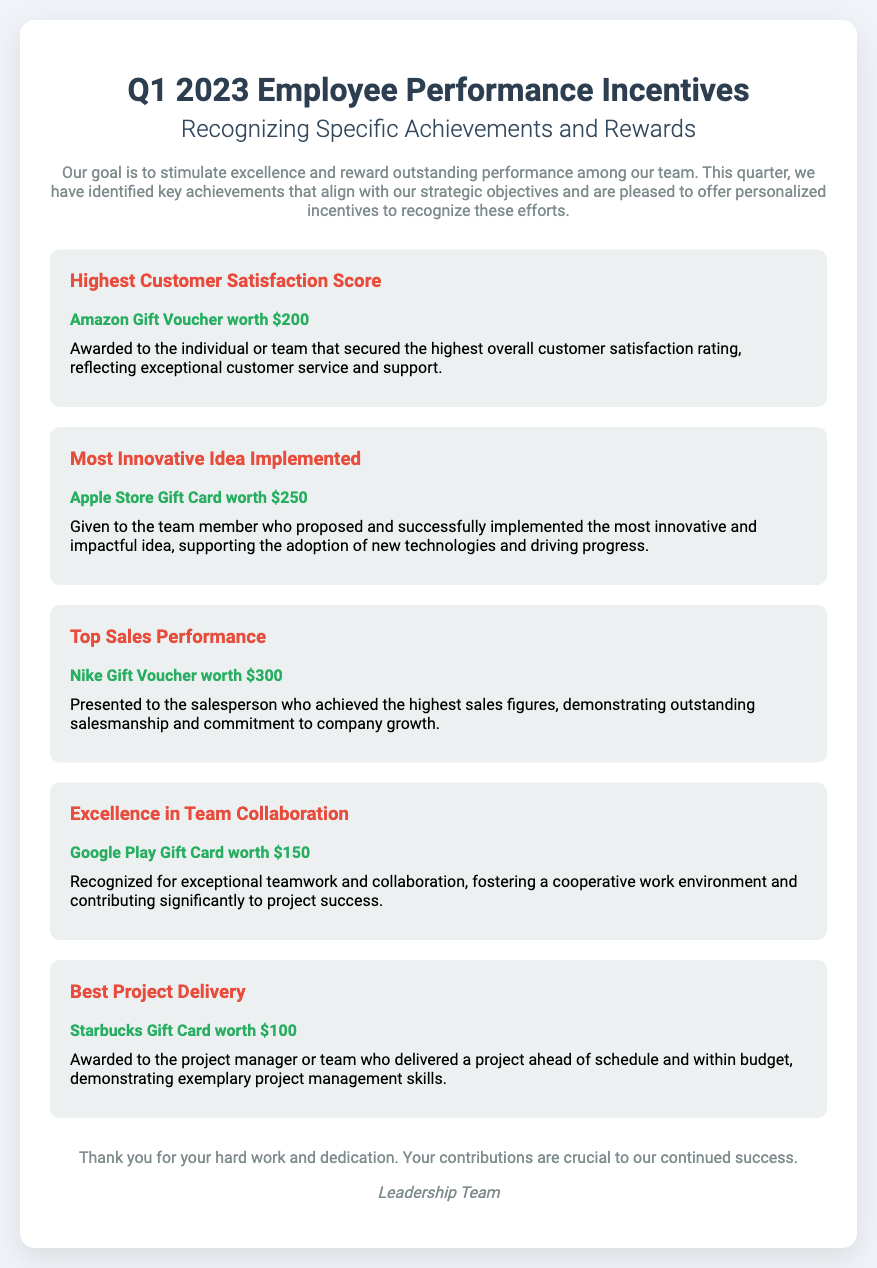What is the title of the document? The title of the document is presented prominently at the top of the rendered document.
Answer: Q1 2023 Employee Performance Incentives How much is the Amazon Gift Voucher worth? The specific value of the Amazon Gift Voucher is stated in the achievement section of the document.
Answer: $200 Who is awarded for the Most Innovative Idea Implemented? The criteria for this award is provided in the context of the achievement section.
Answer: Team member What is the total value of the Top Sales Performance reward? The amount awarded for this achievement can be found in its respective section.
Answer: $300 Which gift card is associated with the Best Project Delivery achievement? The document specifies which gift card is linked to this award.
Answer: Starbucks Gift Card How many specific achievements are recognized in the document? The number of achievements is indicated by the different sections listed in the document.
Answer: Five What is the purpose of the employee performance incentives? The purpose is stated in the introductory paragraph of the document.
Answer: Stimulate excellence What is the gift card type for excellence in team collaboration? The document specifies this type of reward in the respective section for the achievement.
Answer: Google Play Gift Card Who is the document signed by? The last section of the document identifies the signatory or authors of the message.
Answer: Leadership Team 